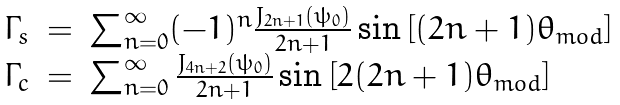Convert formula to latex. <formula><loc_0><loc_0><loc_500><loc_500>\begin{array} { l l l } \Gamma _ { s } & = & \sum _ { n = 0 } ^ { \infty } ( - 1 ) ^ { n } \frac { J _ { 2 n + 1 } ( \psi _ { 0 } ) } { 2 n + 1 } \sin \left [ ( 2 n + 1 ) \theta _ { m o d } \right ] \\ \Gamma _ { c } & = & \sum _ { n = 0 } ^ { \infty } \frac { J _ { 4 n + 2 } ( \psi _ { 0 } ) } { 2 n + 1 } \sin \left [ 2 ( 2 n + 1 ) \theta _ { m o d } \right ] \end{array}</formula> 